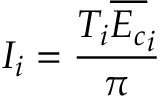<formula> <loc_0><loc_0><loc_500><loc_500>I _ { i } = \frac { T _ { i } \overline { { E _ { c } } } _ { i } } { \pi }</formula> 